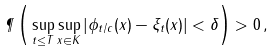Convert formula to latex. <formula><loc_0><loc_0><loc_500><loc_500>\P \left ( \, \sup _ { t \leq T } \sup _ { x \in K } \left | \phi _ { t / c } ( x ) - \xi _ { t } ( x ) \right | < \delta \right ) > 0 \, ,</formula> 